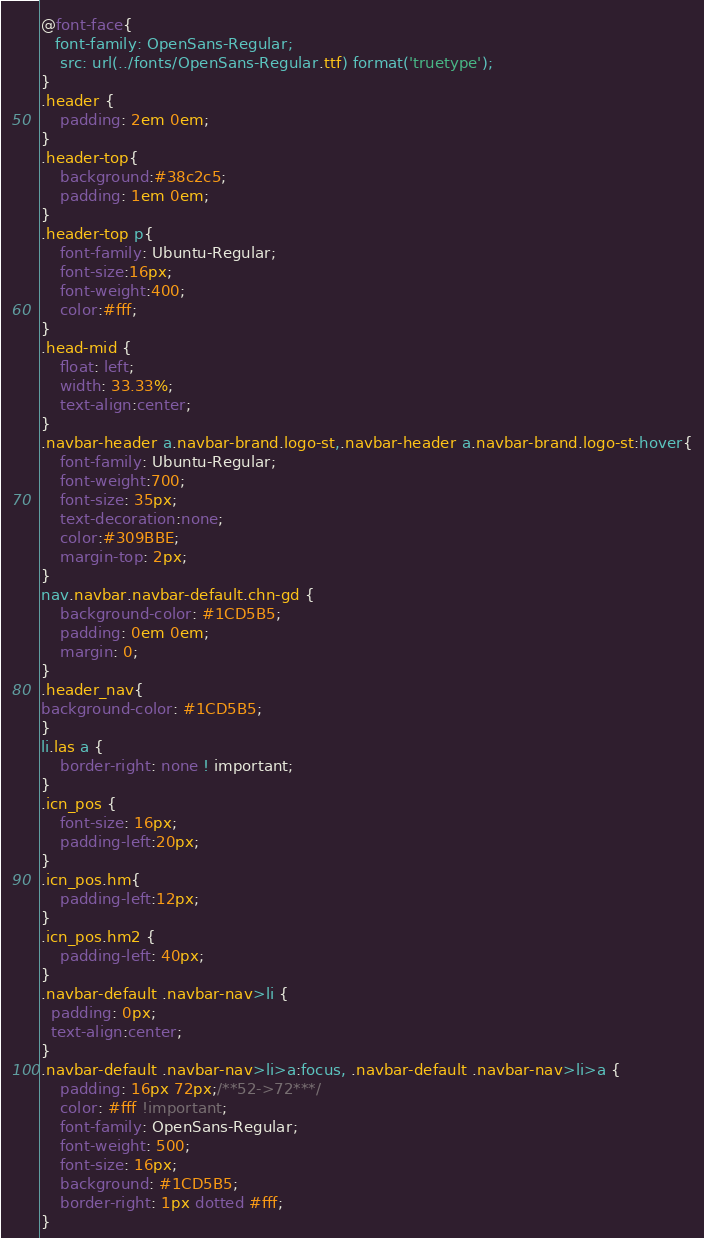Convert code to text. <code><loc_0><loc_0><loc_500><loc_500><_CSS_>@font-face{
   font-family: OpenSans-Regular;
    src: url(../fonts/OpenSans-Regular.ttf) format('truetype');
}
.header {
    padding: 2em 0em;
}
.header-top{
	background:#38c2c5;
	padding: 1em 0em;
}
.header-top p{
	font-family: Ubuntu-Regular;
	font-size:16px;
	font-weight:400;
	color:#fff;
}
.head-mid {
    float: left;
    width: 33.33%;
	text-align:center;
}
.navbar-header a.navbar-brand.logo-st,.navbar-header a.navbar-brand.logo-st:hover{
	font-family: Ubuntu-Regular;
	font-weight:700;
	font-size: 35px;
	text-decoration:none;
	color:#309BBE;
	margin-top: 2px;
}
nav.navbar.navbar-default.chn-gd {
    background-color: #1CD5B5;
    padding: 0em 0em;
    margin: 0;
}
.header_nav{
background-color: #1CD5B5;
}
li.las a {
    border-right: none ! important;
}
.icn_pos {
	font-size: 16px;
	padding-left:20px;
}
.icn_pos.hm{
	padding-left:12px;
}
.icn_pos.hm2 {
	padding-left: 40px;
}
.navbar-default .navbar-nav>li {
  padding: 0px;
  text-align:center;
}
.navbar-default .navbar-nav>li>a:focus, .navbar-default .navbar-nav>li>a {
    padding: 16px 72px;/**52->72***/
    color: #fff !important;
    font-family: OpenSans-Regular;
    font-weight: 500;
    font-size: 16px;
    background: #1CD5B5;
    border-right: 1px dotted #fff;
}</code> 